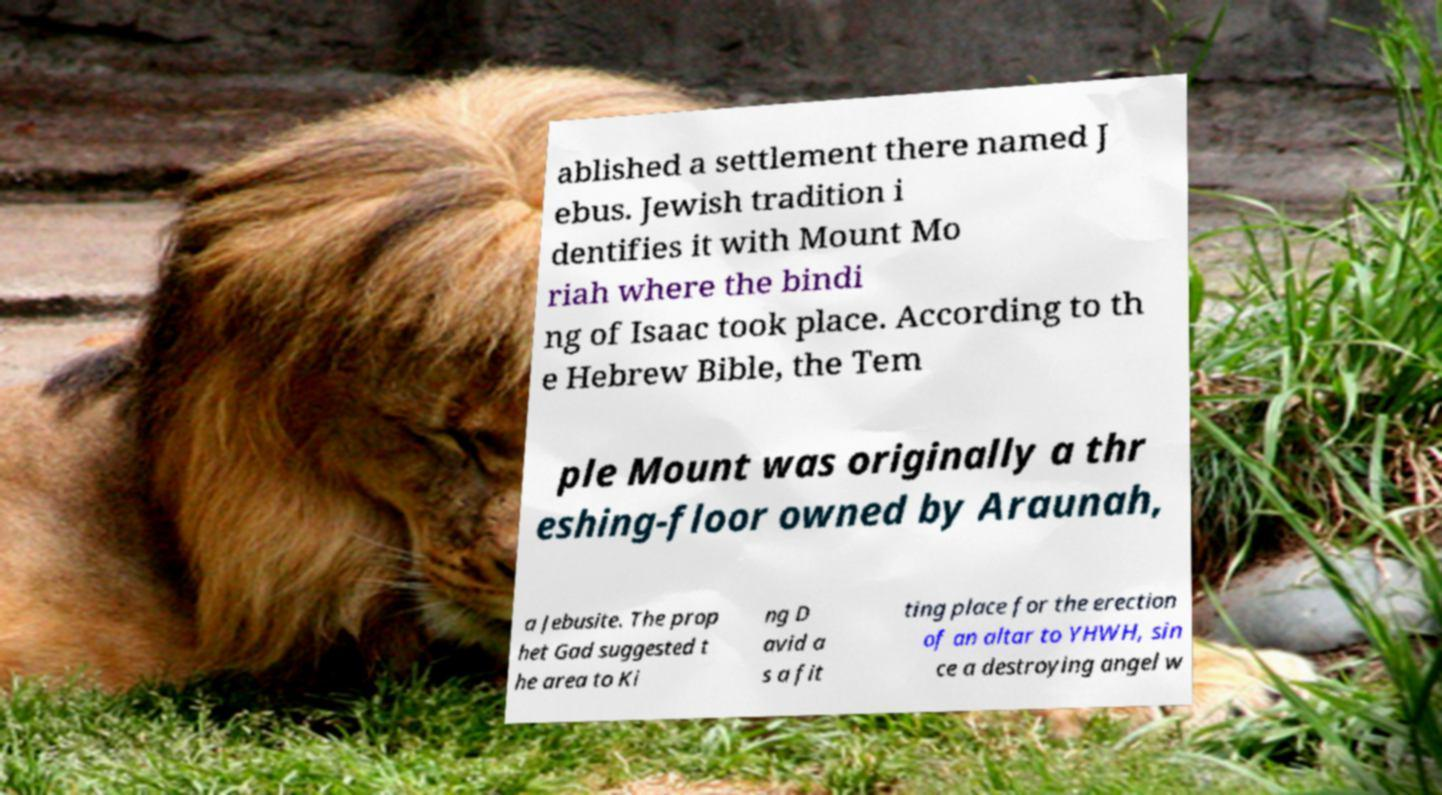Please identify and transcribe the text found in this image. ablished a settlement there named J ebus. Jewish tradition i dentifies it with Mount Mo riah where the bindi ng of Isaac took place. According to th e Hebrew Bible, the Tem ple Mount was originally a thr eshing-floor owned by Araunah, a Jebusite. The prop het Gad suggested t he area to Ki ng D avid a s a fit ting place for the erection of an altar to YHWH, sin ce a destroying angel w 